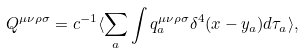<formula> <loc_0><loc_0><loc_500><loc_500>Q ^ { \mu \nu \rho \sigma } = c ^ { - 1 } \langle \sum _ { a } \int q _ { a } ^ { \mu \nu \rho \sigma } \delta ^ { 4 } ( x - y _ { a } ) d \tau _ { a } \rangle ,</formula> 